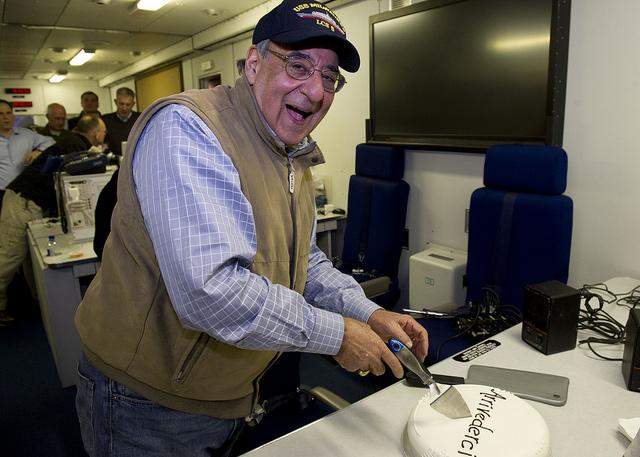How many cakes are there?
Write a very short answer. 1. What is the man cooking?
Answer briefly. Cake. What is the man doing?
Answer briefly. Cutting cake. Does the man seem excited?
Quick response, please. Yes. What is the large, rectangular, black object?
Concise answer only. Speaker. Is this a retirement or going away party?
Be succinct. Retirement. Is this a two-person job?
Short answer required. No. In what branch of the service do these men serve?
Be succinct. Navy. 